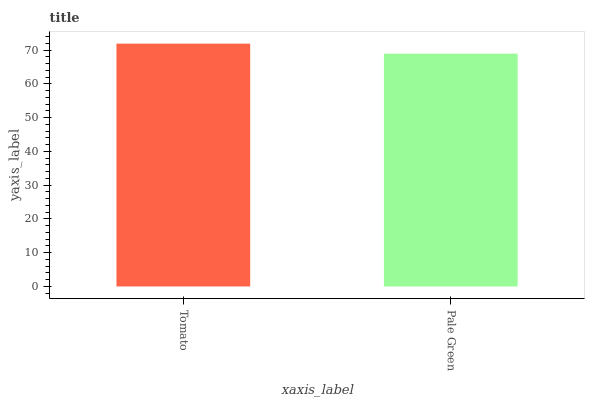Is Pale Green the minimum?
Answer yes or no. Yes. Is Tomato the maximum?
Answer yes or no. Yes. Is Pale Green the maximum?
Answer yes or no. No. Is Tomato greater than Pale Green?
Answer yes or no. Yes. Is Pale Green less than Tomato?
Answer yes or no. Yes. Is Pale Green greater than Tomato?
Answer yes or no. No. Is Tomato less than Pale Green?
Answer yes or no. No. Is Tomato the high median?
Answer yes or no. Yes. Is Pale Green the low median?
Answer yes or no. Yes. Is Pale Green the high median?
Answer yes or no. No. Is Tomato the low median?
Answer yes or no. No. 